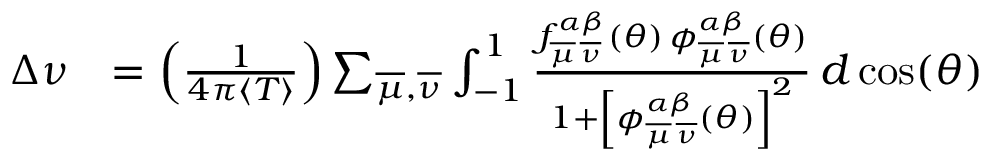<formula> <loc_0><loc_0><loc_500><loc_500>\begin{array} { r l } { \Delta \nu } & { = \left ( \frac { 1 } { 4 \pi \langle T \rangle } \right ) \sum _ { \overline { \mu } , \overline { \nu } } \int _ { - 1 } ^ { 1 } \frac { f _ { \overline { \mu } \, \overline { \nu } } ^ { \alpha \beta } ( \theta ) \, \phi _ { \overline { \mu } \, \overline { \nu } } ^ { \alpha \beta } ( \theta ) } { 1 + \left [ \phi _ { \overline { \mu } \, \overline { \nu } } ^ { \alpha \beta } ( \theta ) \right ] ^ { 2 } } \, d \cos ( \theta ) } \end{array}</formula> 